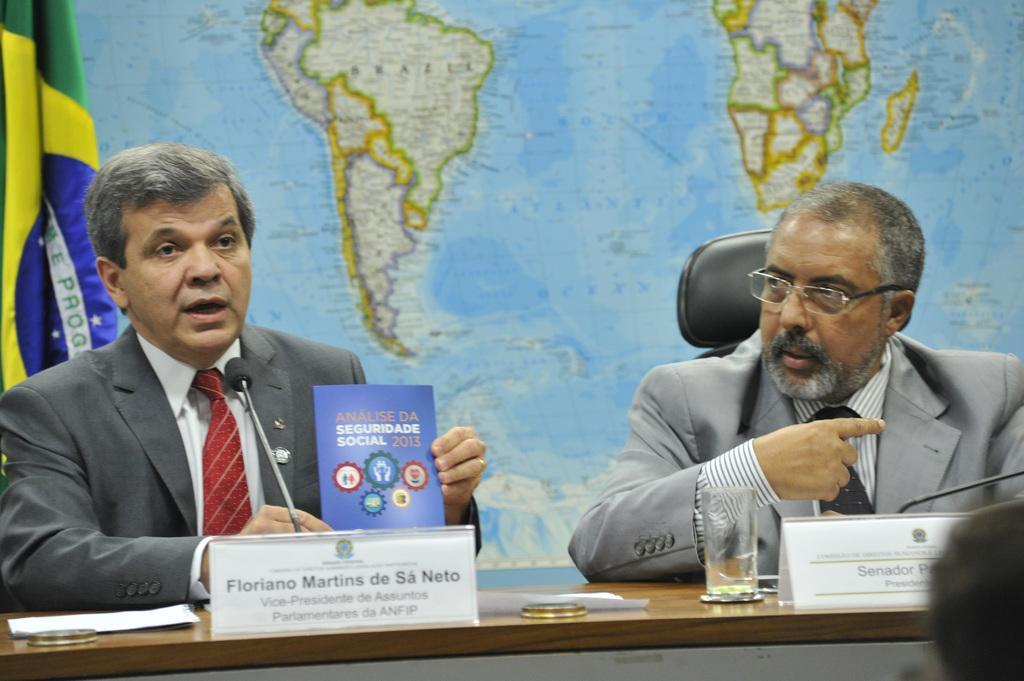Could you give a brief overview of what you see in this image? In this picture we can observe two men sitting in the black color chairs in front of a table on which we can observe a glass and name boards. Both of them were wearing coats. There are mics in front of them. In the background there is a world map. On the left side we can observe a flag. 